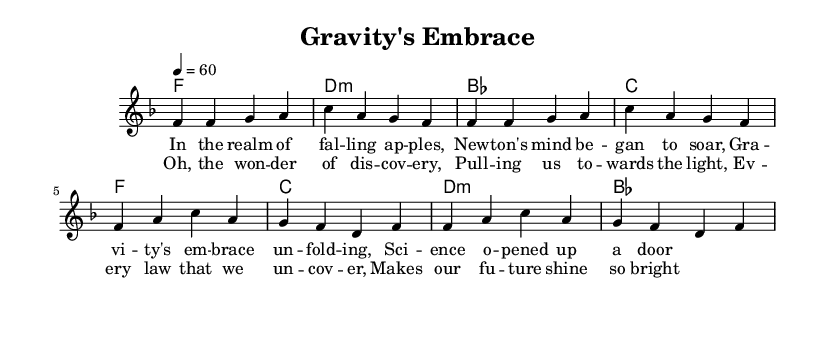What is the key signature of this music? The key signature is F major, which has one flat (B flat) as indicated at the beginning of the staff.
Answer: F major What is the time signature of this music? The time signature is 4/4, as seen next to the clef at the beginning. This indicates that there are four beats in each measure and the quarter note receives one beat.
Answer: 4/4 What is the tempo marking for this piece? The tempo marking is quarter note equals sixty, indicating a slow, steady pace of sixty beats per minute overall.
Answer: 60 How many measures are in the verse? By counting the individual measures in the melody section labeled as verse, you find there are four measures in total for the verse.
Answer: 4 What is the predominant theme of the lyrics? The lyrics celebrate scientific discovery and innovation, specifically focusing on the concept of gravity and the insights gained from it.
Answer: Discovery How do the chorus lyrics reflect the overall message of the piece? The chorus emphasizes wonder and positivity about scientific discoveries, suggesting that understanding the laws of science contributes to a brighter future, which ties back to the theme of celebration in the ballad.
Answer: Celebration What chords are used during the chorus? The chords used in the chorus are F major, C major, D minor, and B flat major, as laid out in the harmonies section.
Answer: F, C, D minor, B flat 